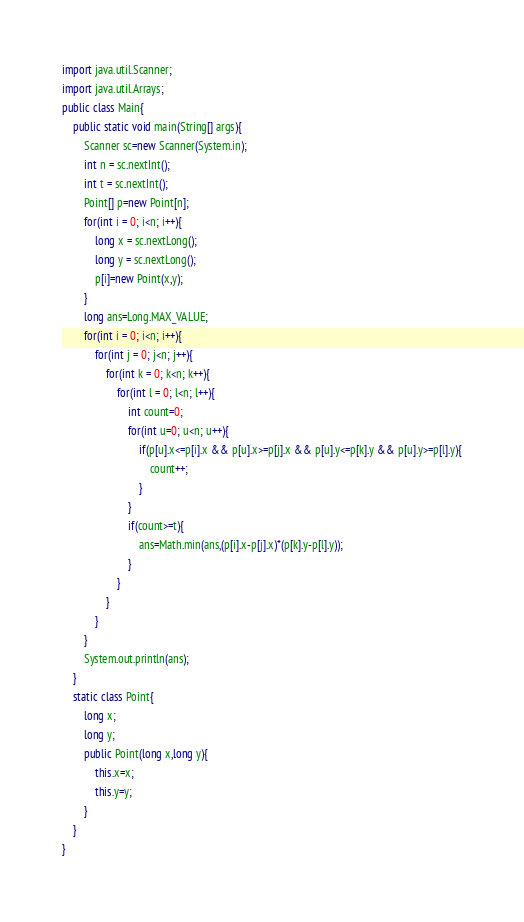Convert code to text. <code><loc_0><loc_0><loc_500><loc_500><_Java_>import java.util.Scanner;
import java.util.Arrays;
public class Main{
	public static void main(String[] args){
		Scanner sc=new Scanner(System.in);
		int n = sc.nextInt();
		int t = sc.nextInt();
		Point[] p=new Point[n];
		for(int i = 0; i<n; i++){
			long x = sc.nextLong();
			long y = sc.nextLong();
			p[i]=new Point(x,y);
		}
		long ans=Long.MAX_VALUE;
		for(int i = 0; i<n; i++){
			for(int j = 0; j<n; j++){
				for(int k = 0; k<n; k++){
					for(int l = 0; l<n; l++){
						int count=0;
						for(int u=0; u<n; u++){
							if(p[u].x<=p[i].x && p[u].x>=p[j].x && p[u].y<=p[k].y && p[u].y>=p[l].y){
								count++;
							}
						}
						if(count>=t){
							ans=Math.min(ans,(p[i].x-p[j].x)*(p[k].y-p[l].y));
						}
					}
				}
			}
		}
		System.out.println(ans);
	}
	static class Point{
		long x;
		long y;
		public Point(long x,long y){
			this.x=x;
			this.y=y;
		}
	}
}
</code> 